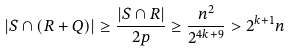Convert formula to latex. <formula><loc_0><loc_0><loc_500><loc_500>| S \cap ( R + Q ) | \geq \frac { | S \cap R | } { 2 p } \geq \frac { n ^ { 2 } } { 2 ^ { 4 k + 9 } } > 2 ^ { k + 1 } n</formula> 